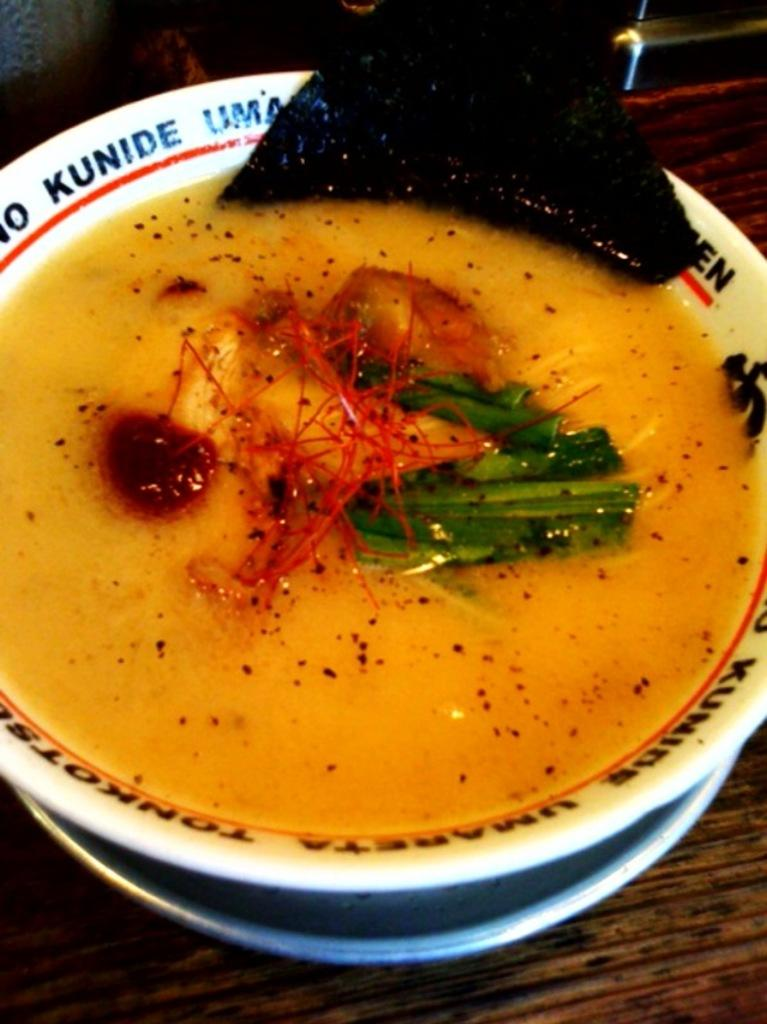What is on the plate that is visible in the image? There is food on a plate in the image. Where is the plate located in the image? The plate is on a table in the image. What type of produce is growing in the cellar in the image? There is no produce or cellar present in the image; it only features a plate of food on a table. 